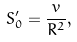<formula> <loc_0><loc_0><loc_500><loc_500>S _ { 0 } ^ { \prime } = \frac { v } { R ^ { 2 } } ,</formula> 